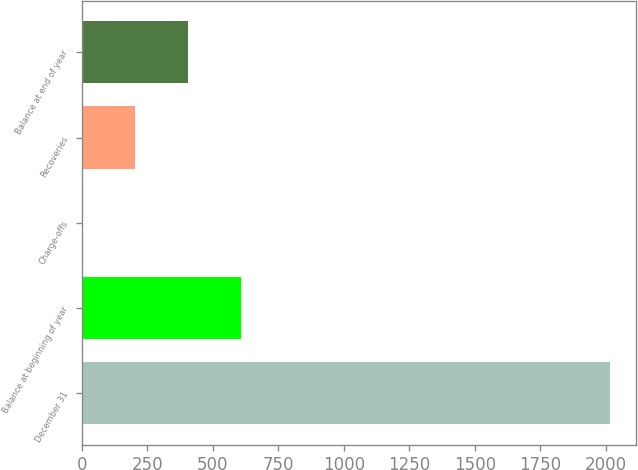<chart> <loc_0><loc_0><loc_500><loc_500><bar_chart><fcel>December 31<fcel>Balance at beginning of year<fcel>Charge-offs<fcel>Recoveries<fcel>Balance at end of year<nl><fcel>2015<fcel>606.6<fcel>3<fcel>204.2<fcel>405.4<nl></chart> 